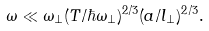Convert formula to latex. <formula><loc_0><loc_0><loc_500><loc_500>\omega \ll \omega _ { \perp } ( T / \hbar { \omega } _ { \perp } ) ^ { 2 / 3 } ( a / l _ { \perp } ) ^ { 2 / 3 } .</formula> 